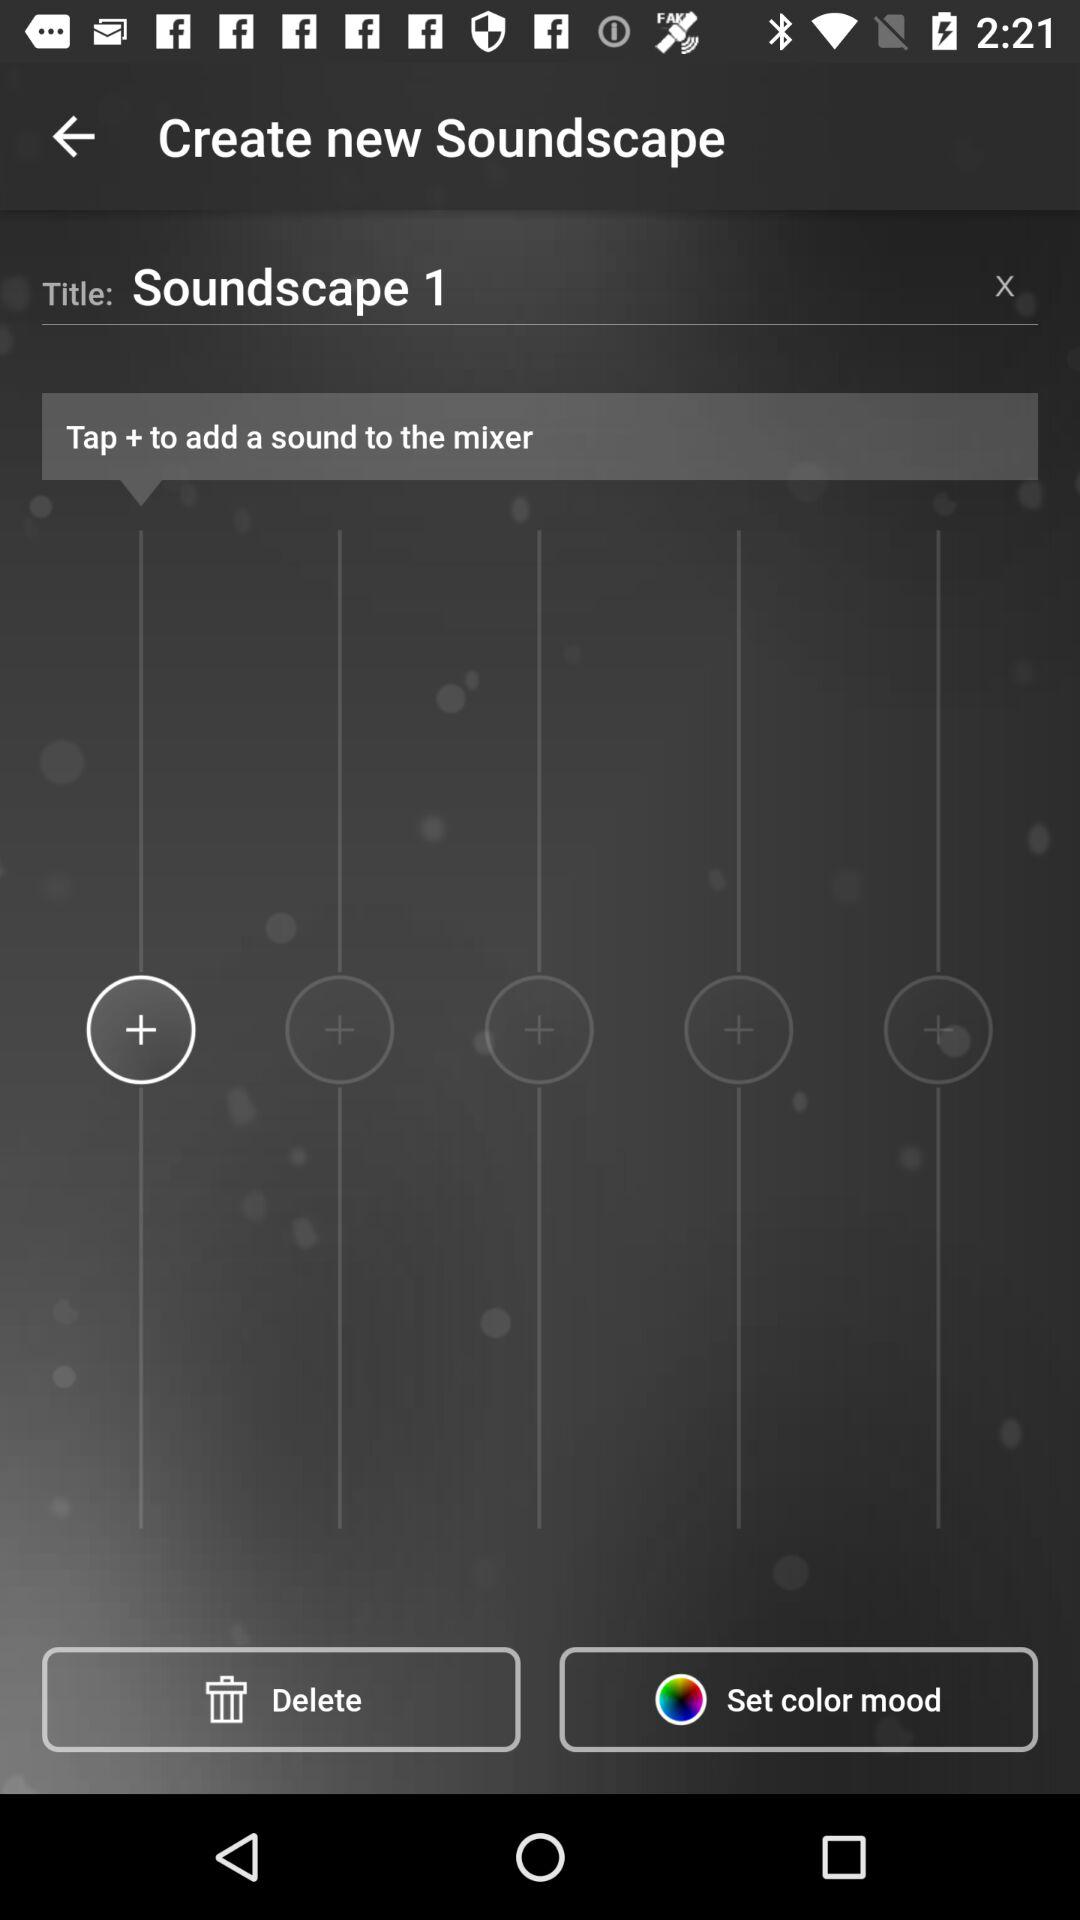What is the title given on the screen? The title given on the screen is "Soundscape 1". 